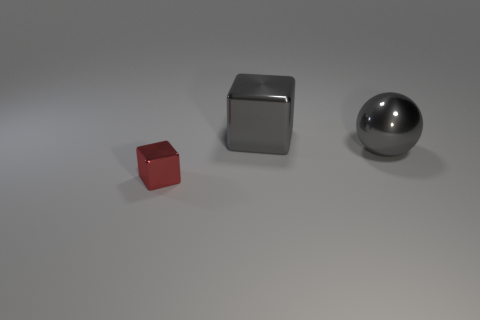Is there any other thing that has the same shape as the tiny red object?
Offer a very short reply. Yes. Is the number of large gray shiny cubes that are behind the large ball greater than the number of cyan cubes?
Your answer should be very brief. Yes. There is a block that is behind the small metal thing; how many tiny red metallic blocks are behind it?
Your answer should be very brief. 0. What is the shape of the gray shiny object on the left side of the large gray object in front of the shiny block on the right side of the red object?
Offer a terse response. Cube. What is the size of the red cube?
Provide a short and direct response. Small. Are there any purple balls made of the same material as the gray ball?
Ensure brevity in your answer.  No. The other gray object that is the same shape as the small object is what size?
Provide a short and direct response. Large. Are there an equal number of tiny metallic things that are on the left side of the small metal block and blue metal balls?
Provide a short and direct response. Yes. There is a big gray object that is right of the big shiny block; is its shape the same as the tiny red metal object?
Your answer should be compact. No. The red thing has what shape?
Give a very brief answer. Cube. 